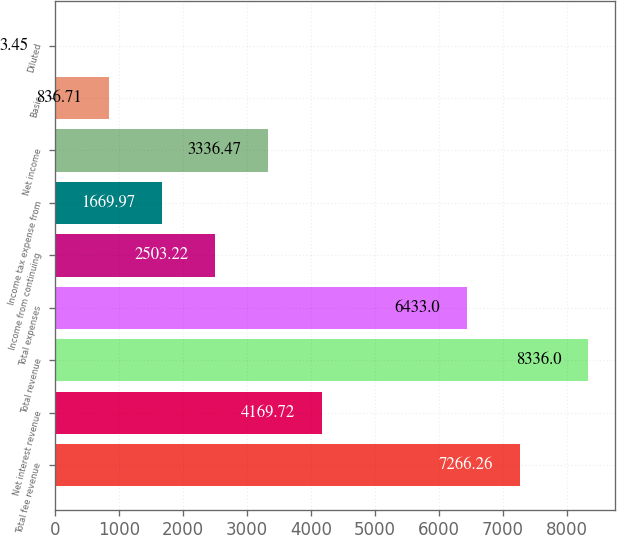Convert chart. <chart><loc_0><loc_0><loc_500><loc_500><bar_chart><fcel>Total fee revenue<fcel>Net interest revenue<fcel>Total revenue<fcel>Total expenses<fcel>Income from continuing<fcel>Income tax expense from<fcel>Net income<fcel>Basic<fcel>Diluted<nl><fcel>7266.26<fcel>4169.72<fcel>8336<fcel>6433<fcel>2503.22<fcel>1669.97<fcel>3336.47<fcel>836.71<fcel>3.45<nl></chart> 